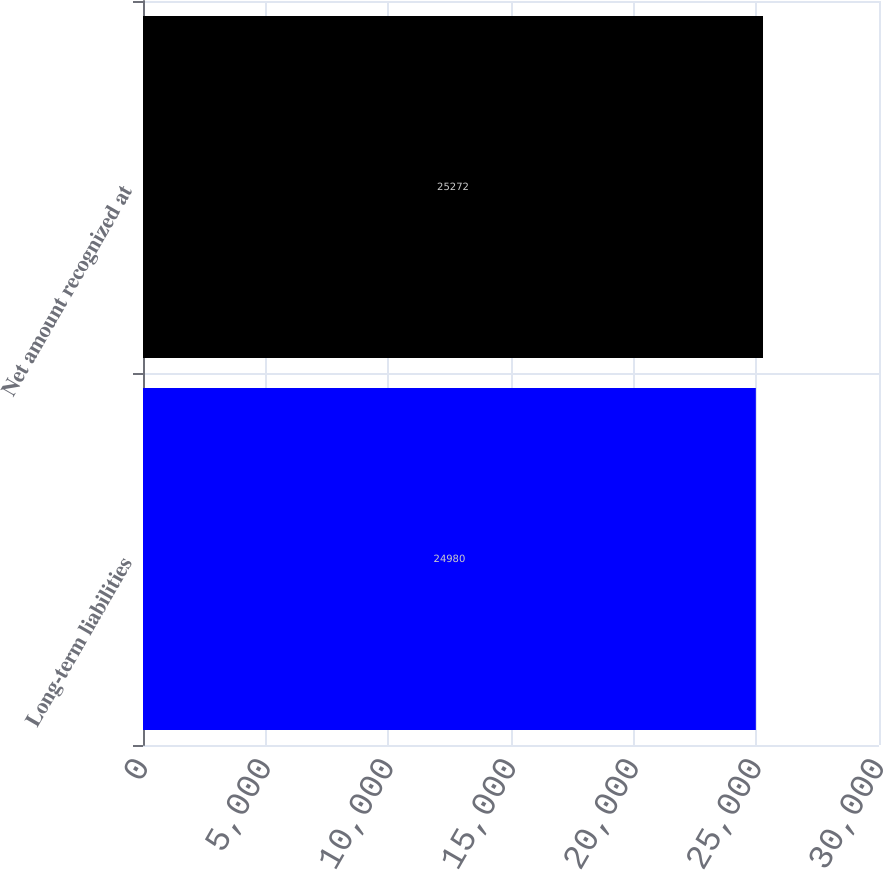Convert chart to OTSL. <chart><loc_0><loc_0><loc_500><loc_500><bar_chart><fcel>Long-term liabilities<fcel>Net amount recognized at<nl><fcel>24980<fcel>25272<nl></chart> 